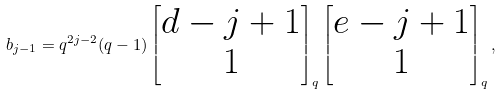<formula> <loc_0><loc_0><loc_500><loc_500>b _ { j - 1 } = q ^ { 2 j - 2 } ( q - 1 ) \left [ \begin{matrix} d - j + 1 \\ 1 \end{matrix} \right ] _ { q } \left [ \begin{matrix} e - j + 1 \\ 1 \end{matrix} \right ] _ { q } ,</formula> 